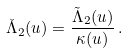<formula> <loc_0><loc_0><loc_500><loc_500>\check { \Lambda } _ { 2 } ( u ) = \frac { \tilde { \Lambda } _ { 2 } ( u ) } { \kappa ( u ) } \, .</formula> 